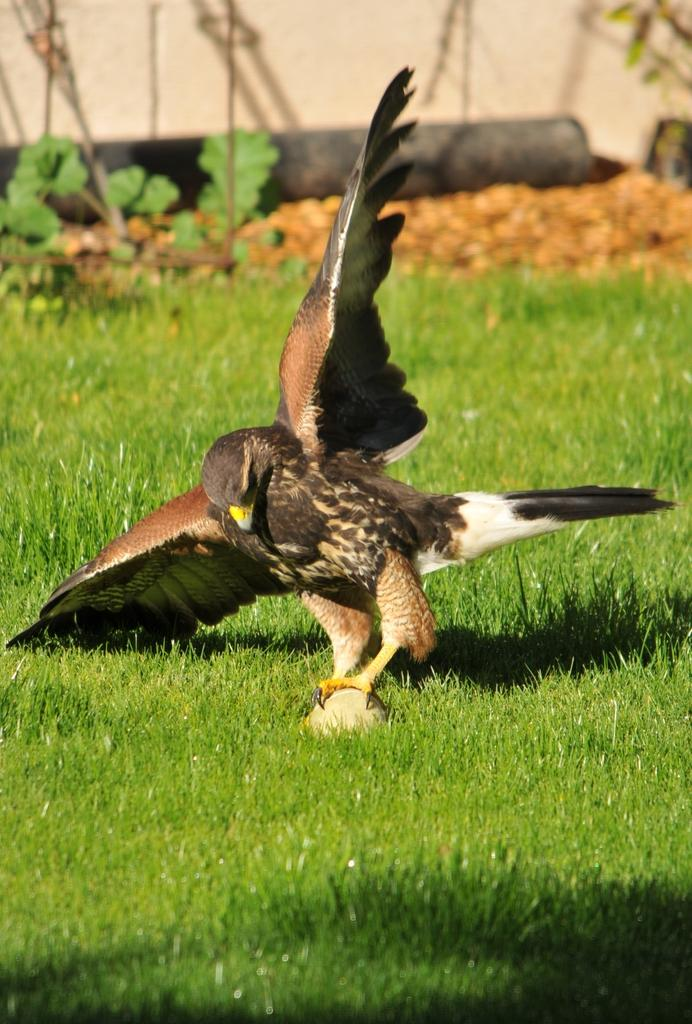What animal can be seen in the picture? There is an eagle in the picture. What is the eagle holding in its legs? The eagle is holding an object with its legs. What is the color of the ground in the picture? The ground in the picture is green. What can be seen in the background of the picture? There are plants and other objects in the background of the picture. What type of milk is being served at the government meeting in the image? There is no mention of milk or a government meeting in the image; it features an eagle holding an object with its legs. 